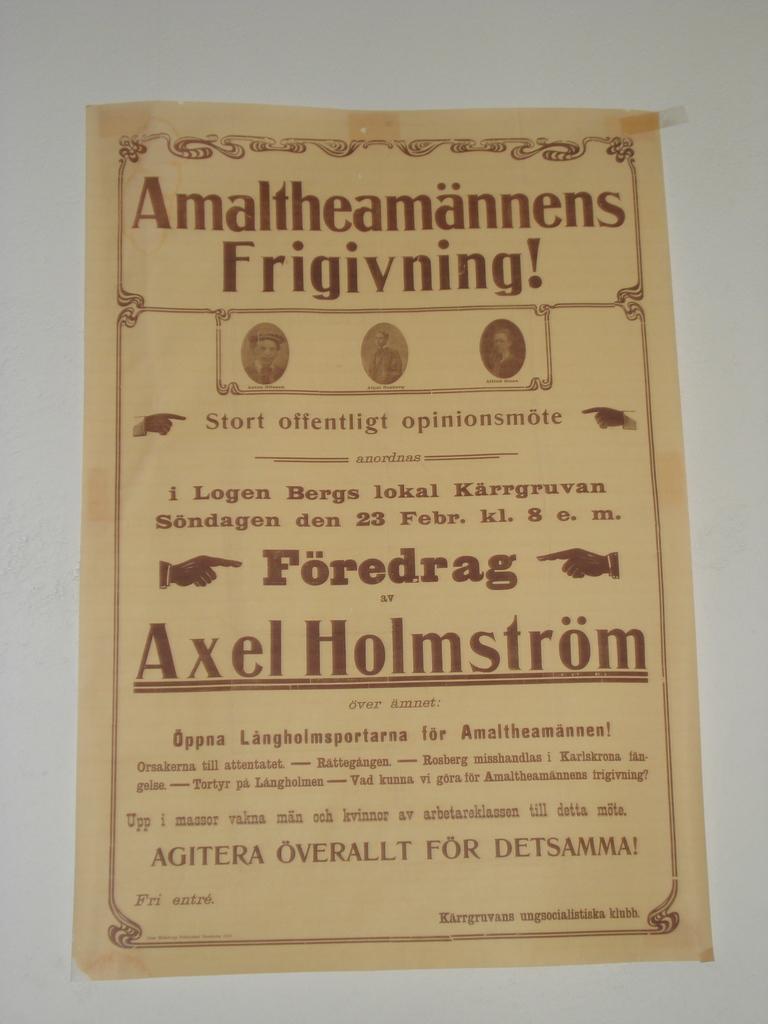What is the title of the piece of paper?
Your response must be concise. Amaltheamannens frigivning!. What name is underlined near the middle?
Make the answer very short. Axel holmstrom. 